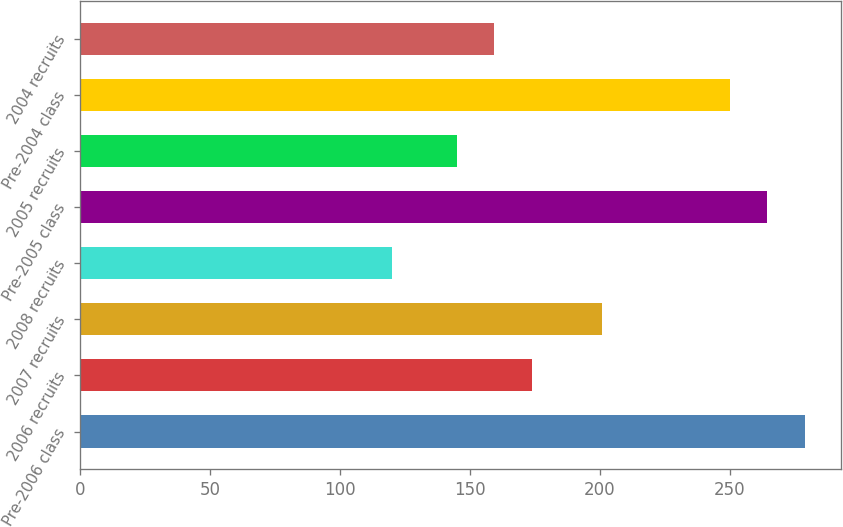<chart> <loc_0><loc_0><loc_500><loc_500><bar_chart><fcel>Pre-2006 class<fcel>2006 recruits<fcel>2007 recruits<fcel>2008 recruits<fcel>Pre-2005 class<fcel>2005 recruits<fcel>Pre-2004 class<fcel>2004 recruits<nl><fcel>278.8<fcel>173.8<fcel>201<fcel>120<fcel>264.4<fcel>145<fcel>250<fcel>159.4<nl></chart> 